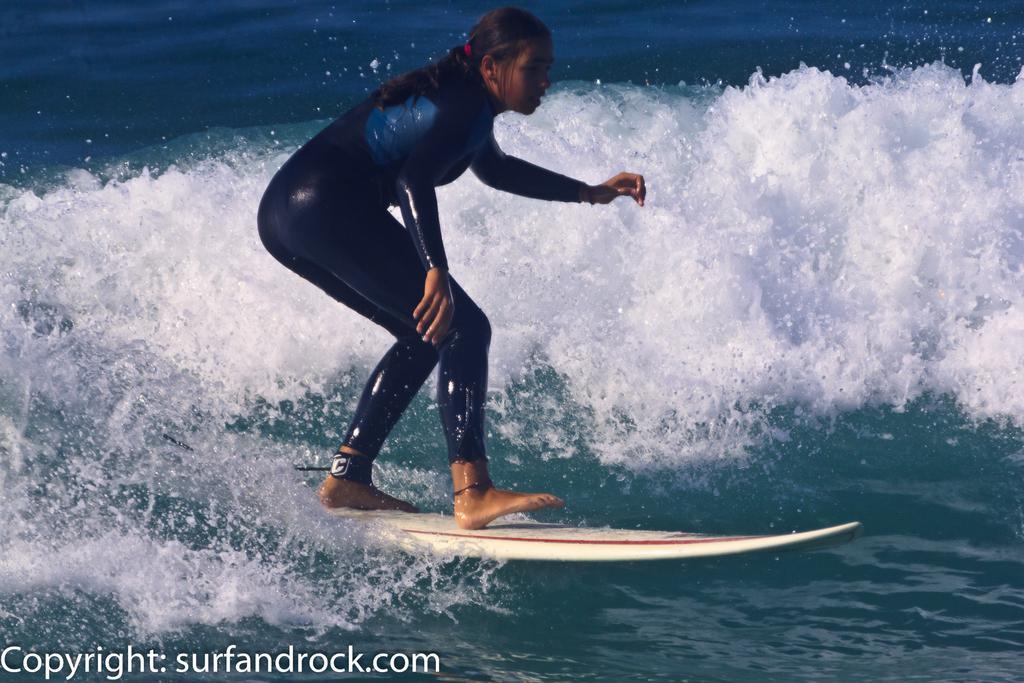How would you summarize this image in a sentence or two? In the picture we can see a girl standing on the surfboard and surfing in the water and the water is blue in color with white color tides. 